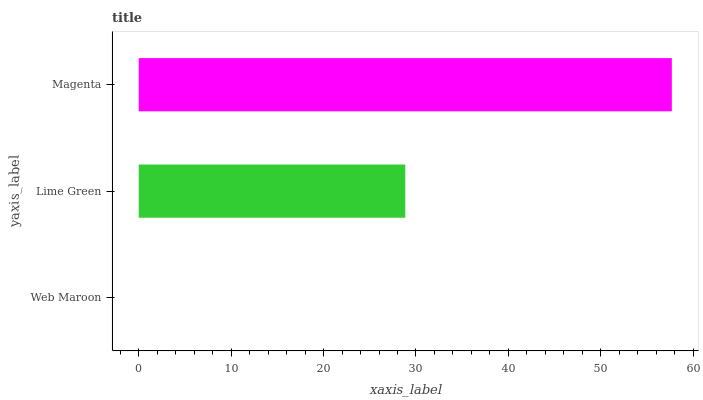Is Web Maroon the minimum?
Answer yes or no. Yes. Is Magenta the maximum?
Answer yes or no. Yes. Is Lime Green the minimum?
Answer yes or no. No. Is Lime Green the maximum?
Answer yes or no. No. Is Lime Green greater than Web Maroon?
Answer yes or no. Yes. Is Web Maroon less than Lime Green?
Answer yes or no. Yes. Is Web Maroon greater than Lime Green?
Answer yes or no. No. Is Lime Green less than Web Maroon?
Answer yes or no. No. Is Lime Green the high median?
Answer yes or no. Yes. Is Lime Green the low median?
Answer yes or no. Yes. Is Magenta the high median?
Answer yes or no. No. Is Magenta the low median?
Answer yes or no. No. 